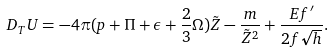<formula> <loc_0><loc_0><loc_500><loc_500>D _ { T } U = - 4 \pi ( p + \Pi + \epsilon + \frac { 2 } { 3 } \Omega ) \tilde { Z } - \frac { m } { \tilde { Z } ^ { 2 } } + \frac { E f ^ { \prime } } { 2 f \sqrt { h } } .</formula> 